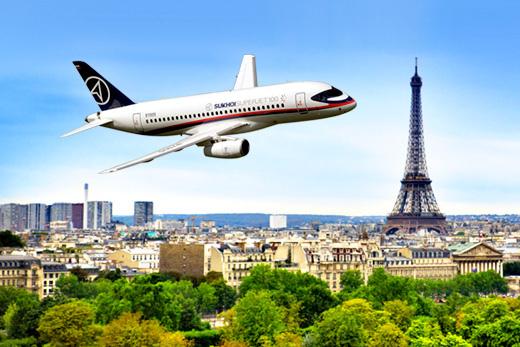What vehicle is in the air?
Be succinct. Plane. What iconic landmark is shown in the background?
Keep it brief. Eiffel tower. Where was this photo taken?
Keep it brief. Paris. 